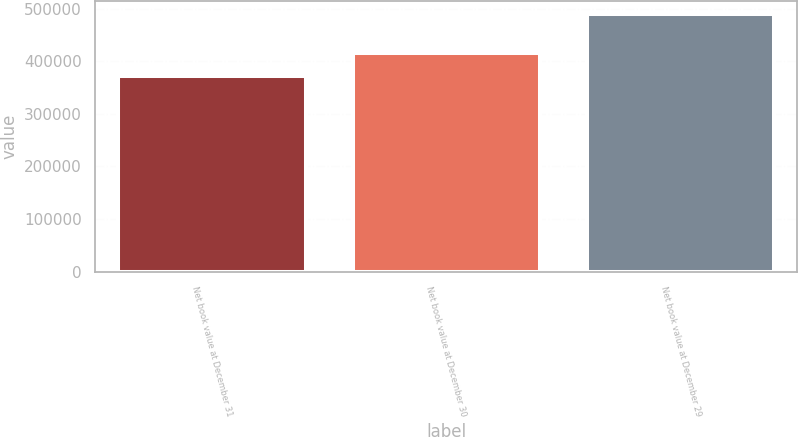<chart> <loc_0><loc_0><loc_500><loc_500><bar_chart><fcel>Net book value at December 31<fcel>Net book value at December 30<fcel>Net book value at December 29<nl><fcel>372312<fcel>415531<fcel>490817<nl></chart> 